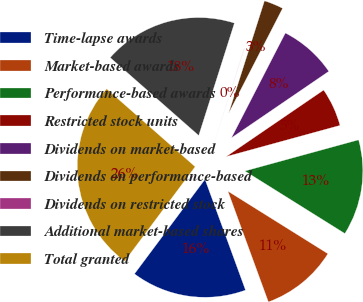<chart> <loc_0><loc_0><loc_500><loc_500><pie_chart><fcel>Time-lapse awards<fcel>Market-based awards<fcel>Performance-based awards<fcel>Restricted stock units<fcel>Dividends on market-based<fcel>Dividends on performance-based<fcel>Dividends on restricted stock<fcel>Additional market-based shares<fcel>Total granted<nl><fcel>15.78%<fcel>10.53%<fcel>13.15%<fcel>5.28%<fcel>7.9%<fcel>2.65%<fcel>0.02%<fcel>18.41%<fcel>26.28%<nl></chart> 